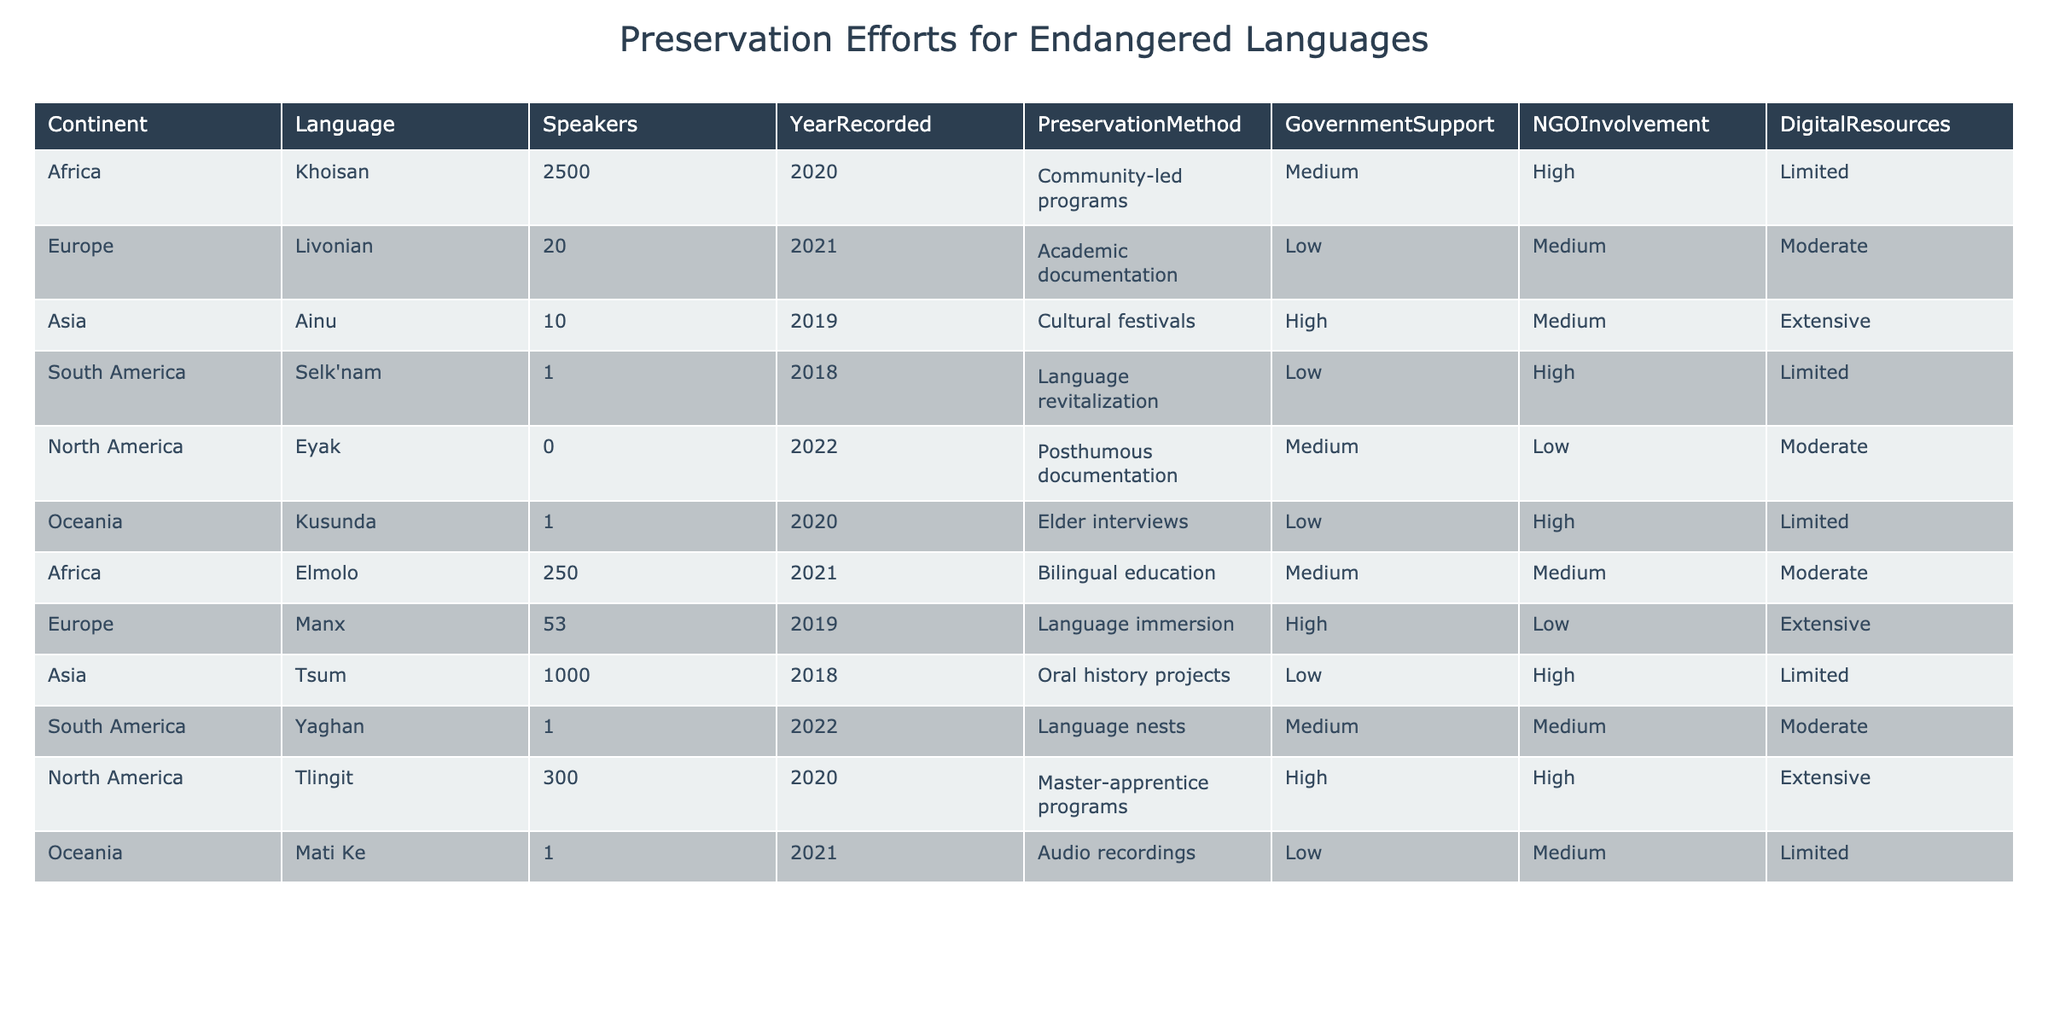What preservation method is used for the Eyak language? The table indicates that the Eyak language uses posthumous documentation as its preservation method.
Answer: Posthumous documentation How many speakers are there for the Ainu language? According to the table, there are 10 speakers of the Ainu language.
Answer: 10 Which continent has the highest number of speakers for endangered languages listed? By reviewing the table, Africa has the highest number of speakers (2,500 for Khoisan) compared to other continents.
Answer: Africa Is there a preservation method involving community-led programs in Africa? Yes, the table shows that Khoisan uses community-led programs for preservation.
Answer: Yes How many languages listed have government support rated as 'High'? The table shows that there are three languages with high government support (Ainu, Tlingit, and Manx).
Answer: 3 What is the average number of speakers across all the languages listed in North America? The speakers in North America are 0 (Eyak) and 300 (Tlingit), totaling 300, and dividing by 2 gives an average of 150.
Answer: 150 Which language has the least number of speakers and what is the preservation method? The language with the least number of speakers is Selk'nam, with 1 speaker, and it uses language revitalization as its preservation method.
Answer: Selk'nam, Language revitalization Are there any languages with 'Extensive' digital resources? Yes, the table shows that Ainu and Tlingit both have extensive digital resources for preservation.
Answer: Yes What type of involvement do NGOs have in the preservation of the Mati Ke language? The table indicates that NGO involvement for the Mati Ke language is rated as 'Medium.'
Answer: Medium What is the difference between the number of speakers in the Khoisan language compared to the Selk'nam language? Khoisan has 2,500 speakers, while Selk'nam has 1 speaker; the difference is 2,500 - 1 = 2,499 speakers.
Answer: 2499 